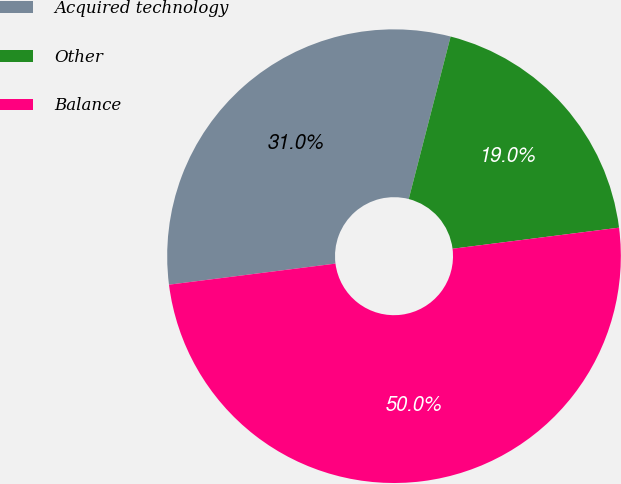<chart> <loc_0><loc_0><loc_500><loc_500><pie_chart><fcel>Acquired technology<fcel>Other<fcel>Balance<nl><fcel>31.02%<fcel>18.98%<fcel>50.0%<nl></chart> 